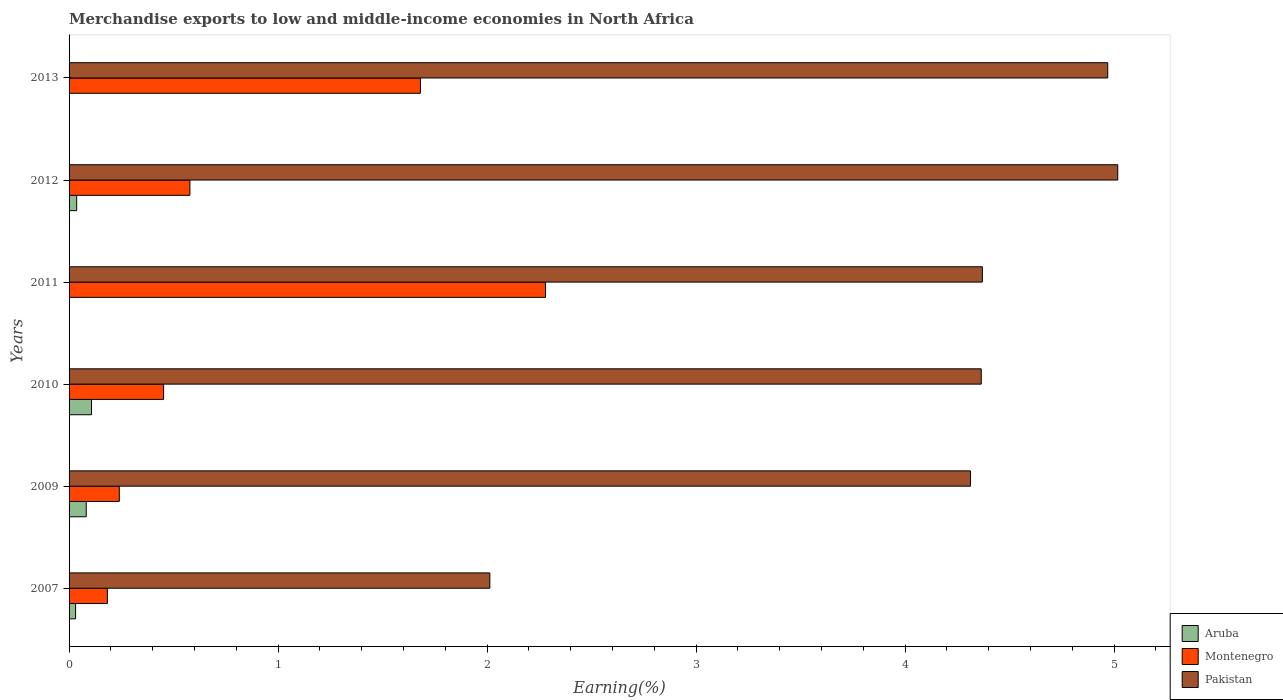How many groups of bars are there?
Keep it short and to the point. 6. Are the number of bars per tick equal to the number of legend labels?
Your response must be concise. Yes. Are the number of bars on each tick of the Y-axis equal?
Your answer should be compact. Yes. How many bars are there on the 1st tick from the top?
Offer a very short reply. 3. In how many cases, is the number of bars for a given year not equal to the number of legend labels?
Make the answer very short. 0. What is the percentage of amount earned from merchandise exports in Pakistan in 2007?
Make the answer very short. 2.01. Across all years, what is the maximum percentage of amount earned from merchandise exports in Pakistan?
Offer a very short reply. 5.02. Across all years, what is the minimum percentage of amount earned from merchandise exports in Pakistan?
Your answer should be very brief. 2.01. In which year was the percentage of amount earned from merchandise exports in Pakistan maximum?
Offer a terse response. 2012. In which year was the percentage of amount earned from merchandise exports in Pakistan minimum?
Your answer should be very brief. 2007. What is the total percentage of amount earned from merchandise exports in Montenegro in the graph?
Make the answer very short. 5.41. What is the difference between the percentage of amount earned from merchandise exports in Pakistan in 2011 and that in 2012?
Keep it short and to the point. -0.65. What is the difference between the percentage of amount earned from merchandise exports in Pakistan in 2009 and the percentage of amount earned from merchandise exports in Aruba in 2012?
Offer a very short reply. 4.28. What is the average percentage of amount earned from merchandise exports in Pakistan per year?
Make the answer very short. 4.17. In the year 2011, what is the difference between the percentage of amount earned from merchandise exports in Aruba and percentage of amount earned from merchandise exports in Pakistan?
Your response must be concise. -4.37. What is the ratio of the percentage of amount earned from merchandise exports in Montenegro in 2010 to that in 2012?
Your response must be concise. 0.78. Is the difference between the percentage of amount earned from merchandise exports in Aruba in 2011 and 2012 greater than the difference between the percentage of amount earned from merchandise exports in Pakistan in 2011 and 2012?
Your answer should be compact. Yes. What is the difference between the highest and the second highest percentage of amount earned from merchandise exports in Pakistan?
Provide a short and direct response. 0.05. What is the difference between the highest and the lowest percentage of amount earned from merchandise exports in Aruba?
Make the answer very short. 0.11. Is the sum of the percentage of amount earned from merchandise exports in Aruba in 2009 and 2010 greater than the maximum percentage of amount earned from merchandise exports in Pakistan across all years?
Provide a short and direct response. No. What does the 1st bar from the bottom in 2007 represents?
Offer a terse response. Aruba. How many bars are there?
Provide a succinct answer. 18. Are all the bars in the graph horizontal?
Your answer should be very brief. Yes. How many years are there in the graph?
Ensure brevity in your answer.  6. Does the graph contain grids?
Provide a short and direct response. No. Where does the legend appear in the graph?
Keep it short and to the point. Bottom right. How many legend labels are there?
Give a very brief answer. 3. What is the title of the graph?
Offer a terse response. Merchandise exports to low and middle-income economies in North Africa. Does "Algeria" appear as one of the legend labels in the graph?
Provide a succinct answer. No. What is the label or title of the X-axis?
Your answer should be compact. Earning(%). What is the label or title of the Y-axis?
Your answer should be compact. Years. What is the Earning(%) in Aruba in 2007?
Your response must be concise. 0.03. What is the Earning(%) in Montenegro in 2007?
Provide a short and direct response. 0.18. What is the Earning(%) in Pakistan in 2007?
Offer a terse response. 2.01. What is the Earning(%) in Aruba in 2009?
Ensure brevity in your answer.  0.08. What is the Earning(%) in Montenegro in 2009?
Your response must be concise. 0.24. What is the Earning(%) of Pakistan in 2009?
Provide a succinct answer. 4.31. What is the Earning(%) in Aruba in 2010?
Provide a succinct answer. 0.11. What is the Earning(%) in Montenegro in 2010?
Offer a terse response. 0.45. What is the Earning(%) in Pakistan in 2010?
Your answer should be very brief. 4.36. What is the Earning(%) in Aruba in 2011?
Keep it short and to the point. 1.99365428786241e-5. What is the Earning(%) of Montenegro in 2011?
Your response must be concise. 2.28. What is the Earning(%) in Pakistan in 2011?
Your answer should be very brief. 4.37. What is the Earning(%) of Aruba in 2012?
Offer a very short reply. 0.04. What is the Earning(%) in Montenegro in 2012?
Offer a terse response. 0.58. What is the Earning(%) of Pakistan in 2012?
Ensure brevity in your answer.  5.02. What is the Earning(%) of Aruba in 2013?
Give a very brief answer. 5.73259172769648e-5. What is the Earning(%) of Montenegro in 2013?
Provide a succinct answer. 1.68. What is the Earning(%) of Pakistan in 2013?
Give a very brief answer. 4.97. Across all years, what is the maximum Earning(%) of Aruba?
Your answer should be very brief. 0.11. Across all years, what is the maximum Earning(%) of Montenegro?
Ensure brevity in your answer.  2.28. Across all years, what is the maximum Earning(%) in Pakistan?
Your answer should be very brief. 5.02. Across all years, what is the minimum Earning(%) of Aruba?
Offer a terse response. 1.99365428786241e-5. Across all years, what is the minimum Earning(%) of Montenegro?
Your response must be concise. 0.18. Across all years, what is the minimum Earning(%) in Pakistan?
Provide a short and direct response. 2.01. What is the total Earning(%) of Aruba in the graph?
Give a very brief answer. 0.26. What is the total Earning(%) of Montenegro in the graph?
Ensure brevity in your answer.  5.41. What is the total Earning(%) in Pakistan in the graph?
Your answer should be compact. 25.05. What is the difference between the Earning(%) of Aruba in 2007 and that in 2009?
Your response must be concise. -0.05. What is the difference between the Earning(%) in Montenegro in 2007 and that in 2009?
Offer a very short reply. -0.06. What is the difference between the Earning(%) of Pakistan in 2007 and that in 2009?
Provide a short and direct response. -2.3. What is the difference between the Earning(%) in Aruba in 2007 and that in 2010?
Your answer should be very brief. -0.08. What is the difference between the Earning(%) of Montenegro in 2007 and that in 2010?
Offer a terse response. -0.27. What is the difference between the Earning(%) in Pakistan in 2007 and that in 2010?
Ensure brevity in your answer.  -2.35. What is the difference between the Earning(%) of Aruba in 2007 and that in 2011?
Make the answer very short. 0.03. What is the difference between the Earning(%) of Montenegro in 2007 and that in 2011?
Your answer should be very brief. -2.1. What is the difference between the Earning(%) of Pakistan in 2007 and that in 2011?
Offer a terse response. -2.36. What is the difference between the Earning(%) of Aruba in 2007 and that in 2012?
Make the answer very short. -0.01. What is the difference between the Earning(%) in Montenegro in 2007 and that in 2012?
Provide a succinct answer. -0.39. What is the difference between the Earning(%) in Pakistan in 2007 and that in 2012?
Keep it short and to the point. -3. What is the difference between the Earning(%) in Aruba in 2007 and that in 2013?
Your answer should be very brief. 0.03. What is the difference between the Earning(%) of Montenegro in 2007 and that in 2013?
Offer a terse response. -1.5. What is the difference between the Earning(%) of Pakistan in 2007 and that in 2013?
Provide a short and direct response. -2.96. What is the difference between the Earning(%) of Aruba in 2009 and that in 2010?
Provide a succinct answer. -0.03. What is the difference between the Earning(%) of Montenegro in 2009 and that in 2010?
Offer a terse response. -0.21. What is the difference between the Earning(%) in Pakistan in 2009 and that in 2010?
Your answer should be compact. -0.05. What is the difference between the Earning(%) of Aruba in 2009 and that in 2011?
Provide a succinct answer. 0.08. What is the difference between the Earning(%) of Montenegro in 2009 and that in 2011?
Your response must be concise. -2.04. What is the difference between the Earning(%) in Pakistan in 2009 and that in 2011?
Provide a succinct answer. -0.06. What is the difference between the Earning(%) of Aruba in 2009 and that in 2012?
Make the answer very short. 0.05. What is the difference between the Earning(%) of Montenegro in 2009 and that in 2012?
Make the answer very short. -0.34. What is the difference between the Earning(%) of Pakistan in 2009 and that in 2012?
Ensure brevity in your answer.  -0.7. What is the difference between the Earning(%) in Aruba in 2009 and that in 2013?
Keep it short and to the point. 0.08. What is the difference between the Earning(%) in Montenegro in 2009 and that in 2013?
Your answer should be compact. -1.44. What is the difference between the Earning(%) of Pakistan in 2009 and that in 2013?
Your response must be concise. -0.66. What is the difference between the Earning(%) of Aruba in 2010 and that in 2011?
Your response must be concise. 0.11. What is the difference between the Earning(%) in Montenegro in 2010 and that in 2011?
Your response must be concise. -1.83. What is the difference between the Earning(%) of Pakistan in 2010 and that in 2011?
Provide a succinct answer. -0.01. What is the difference between the Earning(%) of Aruba in 2010 and that in 2012?
Keep it short and to the point. 0.07. What is the difference between the Earning(%) in Montenegro in 2010 and that in 2012?
Ensure brevity in your answer.  -0.13. What is the difference between the Earning(%) of Pakistan in 2010 and that in 2012?
Provide a succinct answer. -0.65. What is the difference between the Earning(%) of Aruba in 2010 and that in 2013?
Keep it short and to the point. 0.11. What is the difference between the Earning(%) in Montenegro in 2010 and that in 2013?
Offer a terse response. -1.23. What is the difference between the Earning(%) of Pakistan in 2010 and that in 2013?
Ensure brevity in your answer.  -0.6. What is the difference between the Earning(%) in Aruba in 2011 and that in 2012?
Your answer should be compact. -0.04. What is the difference between the Earning(%) of Montenegro in 2011 and that in 2012?
Your answer should be compact. 1.7. What is the difference between the Earning(%) in Pakistan in 2011 and that in 2012?
Make the answer very short. -0.65. What is the difference between the Earning(%) in Aruba in 2011 and that in 2013?
Make the answer very short. -0. What is the difference between the Earning(%) in Montenegro in 2011 and that in 2013?
Your answer should be compact. 0.6. What is the difference between the Earning(%) in Pakistan in 2011 and that in 2013?
Your response must be concise. -0.6. What is the difference between the Earning(%) of Aruba in 2012 and that in 2013?
Keep it short and to the point. 0.04. What is the difference between the Earning(%) of Montenegro in 2012 and that in 2013?
Offer a terse response. -1.1. What is the difference between the Earning(%) in Pakistan in 2012 and that in 2013?
Give a very brief answer. 0.05. What is the difference between the Earning(%) in Aruba in 2007 and the Earning(%) in Montenegro in 2009?
Provide a succinct answer. -0.21. What is the difference between the Earning(%) in Aruba in 2007 and the Earning(%) in Pakistan in 2009?
Make the answer very short. -4.28. What is the difference between the Earning(%) of Montenegro in 2007 and the Earning(%) of Pakistan in 2009?
Offer a terse response. -4.13. What is the difference between the Earning(%) in Aruba in 2007 and the Earning(%) in Montenegro in 2010?
Make the answer very short. -0.42. What is the difference between the Earning(%) of Aruba in 2007 and the Earning(%) of Pakistan in 2010?
Offer a very short reply. -4.33. What is the difference between the Earning(%) in Montenegro in 2007 and the Earning(%) in Pakistan in 2010?
Provide a short and direct response. -4.18. What is the difference between the Earning(%) in Aruba in 2007 and the Earning(%) in Montenegro in 2011?
Offer a terse response. -2.25. What is the difference between the Earning(%) of Aruba in 2007 and the Earning(%) of Pakistan in 2011?
Ensure brevity in your answer.  -4.34. What is the difference between the Earning(%) of Montenegro in 2007 and the Earning(%) of Pakistan in 2011?
Provide a succinct answer. -4.19. What is the difference between the Earning(%) in Aruba in 2007 and the Earning(%) in Montenegro in 2012?
Provide a succinct answer. -0.55. What is the difference between the Earning(%) in Aruba in 2007 and the Earning(%) in Pakistan in 2012?
Ensure brevity in your answer.  -4.99. What is the difference between the Earning(%) of Montenegro in 2007 and the Earning(%) of Pakistan in 2012?
Offer a very short reply. -4.83. What is the difference between the Earning(%) in Aruba in 2007 and the Earning(%) in Montenegro in 2013?
Your answer should be compact. -1.65. What is the difference between the Earning(%) in Aruba in 2007 and the Earning(%) in Pakistan in 2013?
Your answer should be very brief. -4.94. What is the difference between the Earning(%) in Montenegro in 2007 and the Earning(%) in Pakistan in 2013?
Offer a very short reply. -4.79. What is the difference between the Earning(%) of Aruba in 2009 and the Earning(%) of Montenegro in 2010?
Your answer should be compact. -0.37. What is the difference between the Earning(%) of Aruba in 2009 and the Earning(%) of Pakistan in 2010?
Ensure brevity in your answer.  -4.28. What is the difference between the Earning(%) in Montenegro in 2009 and the Earning(%) in Pakistan in 2010?
Your answer should be very brief. -4.12. What is the difference between the Earning(%) in Aruba in 2009 and the Earning(%) in Montenegro in 2011?
Make the answer very short. -2.2. What is the difference between the Earning(%) in Aruba in 2009 and the Earning(%) in Pakistan in 2011?
Offer a terse response. -4.29. What is the difference between the Earning(%) of Montenegro in 2009 and the Earning(%) of Pakistan in 2011?
Provide a short and direct response. -4.13. What is the difference between the Earning(%) of Aruba in 2009 and the Earning(%) of Montenegro in 2012?
Your answer should be compact. -0.5. What is the difference between the Earning(%) of Aruba in 2009 and the Earning(%) of Pakistan in 2012?
Give a very brief answer. -4.93. What is the difference between the Earning(%) in Montenegro in 2009 and the Earning(%) in Pakistan in 2012?
Ensure brevity in your answer.  -4.78. What is the difference between the Earning(%) of Aruba in 2009 and the Earning(%) of Montenegro in 2013?
Provide a short and direct response. -1.6. What is the difference between the Earning(%) of Aruba in 2009 and the Earning(%) of Pakistan in 2013?
Keep it short and to the point. -4.89. What is the difference between the Earning(%) in Montenegro in 2009 and the Earning(%) in Pakistan in 2013?
Provide a short and direct response. -4.73. What is the difference between the Earning(%) in Aruba in 2010 and the Earning(%) in Montenegro in 2011?
Provide a succinct answer. -2.17. What is the difference between the Earning(%) of Aruba in 2010 and the Earning(%) of Pakistan in 2011?
Your answer should be very brief. -4.26. What is the difference between the Earning(%) in Montenegro in 2010 and the Earning(%) in Pakistan in 2011?
Your answer should be compact. -3.92. What is the difference between the Earning(%) of Aruba in 2010 and the Earning(%) of Montenegro in 2012?
Ensure brevity in your answer.  -0.47. What is the difference between the Earning(%) in Aruba in 2010 and the Earning(%) in Pakistan in 2012?
Your response must be concise. -4.91. What is the difference between the Earning(%) of Montenegro in 2010 and the Earning(%) of Pakistan in 2012?
Your answer should be very brief. -4.56. What is the difference between the Earning(%) in Aruba in 2010 and the Earning(%) in Montenegro in 2013?
Your answer should be compact. -1.57. What is the difference between the Earning(%) in Aruba in 2010 and the Earning(%) in Pakistan in 2013?
Your answer should be compact. -4.86. What is the difference between the Earning(%) of Montenegro in 2010 and the Earning(%) of Pakistan in 2013?
Make the answer very short. -4.52. What is the difference between the Earning(%) in Aruba in 2011 and the Earning(%) in Montenegro in 2012?
Your answer should be very brief. -0.58. What is the difference between the Earning(%) of Aruba in 2011 and the Earning(%) of Pakistan in 2012?
Offer a terse response. -5.02. What is the difference between the Earning(%) in Montenegro in 2011 and the Earning(%) in Pakistan in 2012?
Provide a short and direct response. -2.74. What is the difference between the Earning(%) of Aruba in 2011 and the Earning(%) of Montenegro in 2013?
Provide a succinct answer. -1.68. What is the difference between the Earning(%) of Aruba in 2011 and the Earning(%) of Pakistan in 2013?
Your answer should be compact. -4.97. What is the difference between the Earning(%) of Montenegro in 2011 and the Earning(%) of Pakistan in 2013?
Your answer should be compact. -2.69. What is the difference between the Earning(%) of Aruba in 2012 and the Earning(%) of Montenegro in 2013?
Your answer should be very brief. -1.64. What is the difference between the Earning(%) of Aruba in 2012 and the Earning(%) of Pakistan in 2013?
Offer a terse response. -4.93. What is the difference between the Earning(%) in Montenegro in 2012 and the Earning(%) in Pakistan in 2013?
Make the answer very short. -4.39. What is the average Earning(%) of Aruba per year?
Provide a short and direct response. 0.04. What is the average Earning(%) in Montenegro per year?
Offer a terse response. 0.9. What is the average Earning(%) in Pakistan per year?
Ensure brevity in your answer.  4.17. In the year 2007, what is the difference between the Earning(%) of Aruba and Earning(%) of Montenegro?
Provide a succinct answer. -0.15. In the year 2007, what is the difference between the Earning(%) in Aruba and Earning(%) in Pakistan?
Give a very brief answer. -1.98. In the year 2007, what is the difference between the Earning(%) of Montenegro and Earning(%) of Pakistan?
Offer a terse response. -1.83. In the year 2009, what is the difference between the Earning(%) of Aruba and Earning(%) of Montenegro?
Provide a succinct answer. -0.16. In the year 2009, what is the difference between the Earning(%) of Aruba and Earning(%) of Pakistan?
Offer a very short reply. -4.23. In the year 2009, what is the difference between the Earning(%) in Montenegro and Earning(%) in Pakistan?
Offer a very short reply. -4.07. In the year 2010, what is the difference between the Earning(%) in Aruba and Earning(%) in Montenegro?
Give a very brief answer. -0.34. In the year 2010, what is the difference between the Earning(%) in Aruba and Earning(%) in Pakistan?
Give a very brief answer. -4.26. In the year 2010, what is the difference between the Earning(%) of Montenegro and Earning(%) of Pakistan?
Provide a short and direct response. -3.91. In the year 2011, what is the difference between the Earning(%) in Aruba and Earning(%) in Montenegro?
Your response must be concise. -2.28. In the year 2011, what is the difference between the Earning(%) in Aruba and Earning(%) in Pakistan?
Offer a terse response. -4.37. In the year 2011, what is the difference between the Earning(%) of Montenegro and Earning(%) of Pakistan?
Offer a very short reply. -2.09. In the year 2012, what is the difference between the Earning(%) in Aruba and Earning(%) in Montenegro?
Keep it short and to the point. -0.54. In the year 2012, what is the difference between the Earning(%) of Aruba and Earning(%) of Pakistan?
Provide a succinct answer. -4.98. In the year 2012, what is the difference between the Earning(%) of Montenegro and Earning(%) of Pakistan?
Provide a short and direct response. -4.44. In the year 2013, what is the difference between the Earning(%) of Aruba and Earning(%) of Montenegro?
Ensure brevity in your answer.  -1.68. In the year 2013, what is the difference between the Earning(%) in Aruba and Earning(%) in Pakistan?
Your response must be concise. -4.97. In the year 2013, what is the difference between the Earning(%) of Montenegro and Earning(%) of Pakistan?
Your answer should be compact. -3.29. What is the ratio of the Earning(%) of Aruba in 2007 to that in 2009?
Provide a succinct answer. 0.38. What is the ratio of the Earning(%) in Montenegro in 2007 to that in 2009?
Your answer should be very brief. 0.76. What is the ratio of the Earning(%) of Pakistan in 2007 to that in 2009?
Your response must be concise. 0.47. What is the ratio of the Earning(%) of Aruba in 2007 to that in 2010?
Make the answer very short. 0.29. What is the ratio of the Earning(%) in Montenegro in 2007 to that in 2010?
Your answer should be compact. 0.41. What is the ratio of the Earning(%) of Pakistan in 2007 to that in 2010?
Your answer should be very brief. 0.46. What is the ratio of the Earning(%) of Aruba in 2007 to that in 2011?
Keep it short and to the point. 1565.33. What is the ratio of the Earning(%) in Montenegro in 2007 to that in 2011?
Your response must be concise. 0.08. What is the ratio of the Earning(%) of Pakistan in 2007 to that in 2011?
Make the answer very short. 0.46. What is the ratio of the Earning(%) of Aruba in 2007 to that in 2012?
Make the answer very short. 0.86. What is the ratio of the Earning(%) of Montenegro in 2007 to that in 2012?
Offer a very short reply. 0.32. What is the ratio of the Earning(%) of Pakistan in 2007 to that in 2012?
Offer a terse response. 0.4. What is the ratio of the Earning(%) in Aruba in 2007 to that in 2013?
Make the answer very short. 544.38. What is the ratio of the Earning(%) of Montenegro in 2007 to that in 2013?
Ensure brevity in your answer.  0.11. What is the ratio of the Earning(%) of Pakistan in 2007 to that in 2013?
Your answer should be very brief. 0.41. What is the ratio of the Earning(%) in Aruba in 2009 to that in 2010?
Make the answer very short. 0.76. What is the ratio of the Earning(%) in Montenegro in 2009 to that in 2010?
Keep it short and to the point. 0.53. What is the ratio of the Earning(%) in Pakistan in 2009 to that in 2010?
Ensure brevity in your answer.  0.99. What is the ratio of the Earning(%) in Aruba in 2009 to that in 2011?
Make the answer very short. 4117.13. What is the ratio of the Earning(%) in Montenegro in 2009 to that in 2011?
Offer a terse response. 0.11. What is the ratio of the Earning(%) in Pakistan in 2009 to that in 2011?
Your answer should be compact. 0.99. What is the ratio of the Earning(%) in Aruba in 2009 to that in 2012?
Make the answer very short. 2.25. What is the ratio of the Earning(%) of Montenegro in 2009 to that in 2012?
Your answer should be compact. 0.42. What is the ratio of the Earning(%) in Pakistan in 2009 to that in 2012?
Keep it short and to the point. 0.86. What is the ratio of the Earning(%) in Aruba in 2009 to that in 2013?
Provide a succinct answer. 1431.84. What is the ratio of the Earning(%) in Montenegro in 2009 to that in 2013?
Offer a terse response. 0.14. What is the ratio of the Earning(%) in Pakistan in 2009 to that in 2013?
Your answer should be very brief. 0.87. What is the ratio of the Earning(%) in Aruba in 2010 to that in 2011?
Offer a terse response. 5391.54. What is the ratio of the Earning(%) of Montenegro in 2010 to that in 2011?
Your answer should be very brief. 0.2. What is the ratio of the Earning(%) in Pakistan in 2010 to that in 2011?
Keep it short and to the point. 1. What is the ratio of the Earning(%) in Aruba in 2010 to that in 2012?
Provide a short and direct response. 2.95. What is the ratio of the Earning(%) in Montenegro in 2010 to that in 2012?
Offer a terse response. 0.78. What is the ratio of the Earning(%) of Pakistan in 2010 to that in 2012?
Keep it short and to the point. 0.87. What is the ratio of the Earning(%) in Aruba in 2010 to that in 2013?
Ensure brevity in your answer.  1875.05. What is the ratio of the Earning(%) in Montenegro in 2010 to that in 2013?
Your response must be concise. 0.27. What is the ratio of the Earning(%) of Pakistan in 2010 to that in 2013?
Provide a succinct answer. 0.88. What is the ratio of the Earning(%) of Aruba in 2011 to that in 2012?
Offer a terse response. 0. What is the ratio of the Earning(%) in Montenegro in 2011 to that in 2012?
Your answer should be very brief. 3.94. What is the ratio of the Earning(%) in Pakistan in 2011 to that in 2012?
Give a very brief answer. 0.87. What is the ratio of the Earning(%) of Aruba in 2011 to that in 2013?
Offer a very short reply. 0.35. What is the ratio of the Earning(%) in Montenegro in 2011 to that in 2013?
Offer a very short reply. 1.36. What is the ratio of the Earning(%) of Pakistan in 2011 to that in 2013?
Your response must be concise. 0.88. What is the ratio of the Earning(%) of Aruba in 2012 to that in 2013?
Provide a short and direct response. 635.36. What is the ratio of the Earning(%) in Montenegro in 2012 to that in 2013?
Ensure brevity in your answer.  0.34. What is the ratio of the Earning(%) in Pakistan in 2012 to that in 2013?
Offer a terse response. 1.01. What is the difference between the highest and the second highest Earning(%) in Aruba?
Make the answer very short. 0.03. What is the difference between the highest and the second highest Earning(%) of Montenegro?
Offer a terse response. 0.6. What is the difference between the highest and the second highest Earning(%) of Pakistan?
Your answer should be very brief. 0.05. What is the difference between the highest and the lowest Earning(%) in Aruba?
Keep it short and to the point. 0.11. What is the difference between the highest and the lowest Earning(%) of Montenegro?
Ensure brevity in your answer.  2.1. What is the difference between the highest and the lowest Earning(%) in Pakistan?
Make the answer very short. 3. 